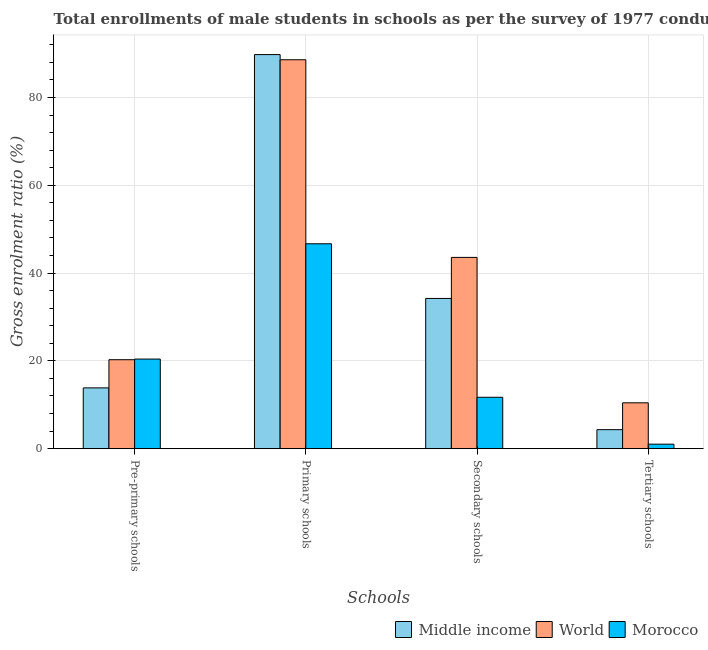How many groups of bars are there?
Make the answer very short. 4. Are the number of bars on each tick of the X-axis equal?
Make the answer very short. Yes. How many bars are there on the 4th tick from the left?
Give a very brief answer. 3. What is the label of the 3rd group of bars from the left?
Ensure brevity in your answer.  Secondary schools. What is the gross enrolment ratio(male) in pre-primary schools in Middle income?
Ensure brevity in your answer.  13.85. Across all countries, what is the maximum gross enrolment ratio(male) in tertiary schools?
Ensure brevity in your answer.  10.44. Across all countries, what is the minimum gross enrolment ratio(male) in pre-primary schools?
Provide a succinct answer. 13.85. In which country was the gross enrolment ratio(male) in secondary schools minimum?
Offer a terse response. Morocco. What is the total gross enrolment ratio(male) in pre-primary schools in the graph?
Your answer should be very brief. 54.52. What is the difference between the gross enrolment ratio(male) in secondary schools in Middle income and that in Morocco?
Your response must be concise. 22.51. What is the difference between the gross enrolment ratio(male) in primary schools in World and the gross enrolment ratio(male) in pre-primary schools in Morocco?
Provide a succinct answer. 68.17. What is the average gross enrolment ratio(male) in secondary schools per country?
Keep it short and to the point. 29.83. What is the difference between the gross enrolment ratio(male) in secondary schools and gross enrolment ratio(male) in pre-primary schools in World?
Offer a terse response. 23.31. In how many countries, is the gross enrolment ratio(male) in primary schools greater than 68 %?
Your answer should be very brief. 2. What is the ratio of the gross enrolment ratio(male) in tertiary schools in Middle income to that in World?
Provide a succinct answer. 0.41. Is the difference between the gross enrolment ratio(male) in primary schools in Morocco and World greater than the difference between the gross enrolment ratio(male) in secondary schools in Morocco and World?
Your response must be concise. No. What is the difference between the highest and the second highest gross enrolment ratio(male) in pre-primary schools?
Make the answer very short. 0.15. What is the difference between the highest and the lowest gross enrolment ratio(male) in pre-primary schools?
Offer a terse response. 6.56. What does the 3rd bar from the left in Pre-primary schools represents?
Your answer should be compact. Morocco. What does the 2nd bar from the right in Pre-primary schools represents?
Your answer should be very brief. World. How many bars are there?
Provide a succinct answer. 12. Are all the bars in the graph horizontal?
Offer a very short reply. No. How many countries are there in the graph?
Provide a succinct answer. 3. Where does the legend appear in the graph?
Keep it short and to the point. Bottom right. What is the title of the graph?
Give a very brief answer. Total enrollments of male students in schools as per the survey of 1977 conducted in different countries. Does "Burkina Faso" appear as one of the legend labels in the graph?
Keep it short and to the point. No. What is the label or title of the X-axis?
Provide a short and direct response. Schools. What is the Gross enrolment ratio (%) in Middle income in Pre-primary schools?
Ensure brevity in your answer.  13.85. What is the Gross enrolment ratio (%) in World in Pre-primary schools?
Make the answer very short. 20.26. What is the Gross enrolment ratio (%) in Morocco in Pre-primary schools?
Provide a succinct answer. 20.41. What is the Gross enrolment ratio (%) in Middle income in Primary schools?
Your answer should be compact. 89.76. What is the Gross enrolment ratio (%) in World in Primary schools?
Provide a short and direct response. 88.58. What is the Gross enrolment ratio (%) in Morocco in Primary schools?
Offer a very short reply. 46.67. What is the Gross enrolment ratio (%) in Middle income in Secondary schools?
Give a very brief answer. 34.22. What is the Gross enrolment ratio (%) of World in Secondary schools?
Provide a succinct answer. 43.57. What is the Gross enrolment ratio (%) in Morocco in Secondary schools?
Make the answer very short. 11.71. What is the Gross enrolment ratio (%) in Middle income in Tertiary schools?
Make the answer very short. 4.33. What is the Gross enrolment ratio (%) in World in Tertiary schools?
Offer a very short reply. 10.44. What is the Gross enrolment ratio (%) in Morocco in Tertiary schools?
Your answer should be compact. 1.03. Across all Schools, what is the maximum Gross enrolment ratio (%) in Middle income?
Provide a succinct answer. 89.76. Across all Schools, what is the maximum Gross enrolment ratio (%) in World?
Offer a very short reply. 88.58. Across all Schools, what is the maximum Gross enrolment ratio (%) in Morocco?
Offer a terse response. 46.67. Across all Schools, what is the minimum Gross enrolment ratio (%) of Middle income?
Ensure brevity in your answer.  4.33. Across all Schools, what is the minimum Gross enrolment ratio (%) of World?
Keep it short and to the point. 10.44. Across all Schools, what is the minimum Gross enrolment ratio (%) of Morocco?
Ensure brevity in your answer.  1.03. What is the total Gross enrolment ratio (%) in Middle income in the graph?
Offer a very short reply. 142.16. What is the total Gross enrolment ratio (%) in World in the graph?
Ensure brevity in your answer.  162.86. What is the total Gross enrolment ratio (%) in Morocco in the graph?
Your answer should be very brief. 79.82. What is the difference between the Gross enrolment ratio (%) of Middle income in Pre-primary schools and that in Primary schools?
Offer a very short reply. -75.92. What is the difference between the Gross enrolment ratio (%) in World in Pre-primary schools and that in Primary schools?
Your response must be concise. -68.32. What is the difference between the Gross enrolment ratio (%) of Morocco in Pre-primary schools and that in Primary schools?
Ensure brevity in your answer.  -26.26. What is the difference between the Gross enrolment ratio (%) of Middle income in Pre-primary schools and that in Secondary schools?
Your response must be concise. -20.37. What is the difference between the Gross enrolment ratio (%) of World in Pre-primary schools and that in Secondary schools?
Give a very brief answer. -23.31. What is the difference between the Gross enrolment ratio (%) in Morocco in Pre-primary schools and that in Secondary schools?
Make the answer very short. 8.7. What is the difference between the Gross enrolment ratio (%) in Middle income in Pre-primary schools and that in Tertiary schools?
Keep it short and to the point. 9.52. What is the difference between the Gross enrolment ratio (%) in World in Pre-primary schools and that in Tertiary schools?
Ensure brevity in your answer.  9.82. What is the difference between the Gross enrolment ratio (%) of Morocco in Pre-primary schools and that in Tertiary schools?
Your answer should be compact. 19.38. What is the difference between the Gross enrolment ratio (%) in Middle income in Primary schools and that in Secondary schools?
Offer a very short reply. 55.55. What is the difference between the Gross enrolment ratio (%) in World in Primary schools and that in Secondary schools?
Offer a very short reply. 45.02. What is the difference between the Gross enrolment ratio (%) in Morocco in Primary schools and that in Secondary schools?
Keep it short and to the point. 34.96. What is the difference between the Gross enrolment ratio (%) of Middle income in Primary schools and that in Tertiary schools?
Ensure brevity in your answer.  85.43. What is the difference between the Gross enrolment ratio (%) in World in Primary schools and that in Tertiary schools?
Provide a short and direct response. 78.14. What is the difference between the Gross enrolment ratio (%) in Morocco in Primary schools and that in Tertiary schools?
Your answer should be very brief. 45.64. What is the difference between the Gross enrolment ratio (%) in Middle income in Secondary schools and that in Tertiary schools?
Your answer should be compact. 29.89. What is the difference between the Gross enrolment ratio (%) of World in Secondary schools and that in Tertiary schools?
Give a very brief answer. 33.12. What is the difference between the Gross enrolment ratio (%) in Morocco in Secondary schools and that in Tertiary schools?
Ensure brevity in your answer.  10.68. What is the difference between the Gross enrolment ratio (%) in Middle income in Pre-primary schools and the Gross enrolment ratio (%) in World in Primary schools?
Your answer should be compact. -74.74. What is the difference between the Gross enrolment ratio (%) in Middle income in Pre-primary schools and the Gross enrolment ratio (%) in Morocco in Primary schools?
Your answer should be compact. -32.82. What is the difference between the Gross enrolment ratio (%) in World in Pre-primary schools and the Gross enrolment ratio (%) in Morocco in Primary schools?
Ensure brevity in your answer.  -26.41. What is the difference between the Gross enrolment ratio (%) of Middle income in Pre-primary schools and the Gross enrolment ratio (%) of World in Secondary schools?
Make the answer very short. -29.72. What is the difference between the Gross enrolment ratio (%) of Middle income in Pre-primary schools and the Gross enrolment ratio (%) of Morocco in Secondary schools?
Give a very brief answer. 2.14. What is the difference between the Gross enrolment ratio (%) in World in Pre-primary schools and the Gross enrolment ratio (%) in Morocco in Secondary schools?
Offer a very short reply. 8.56. What is the difference between the Gross enrolment ratio (%) in Middle income in Pre-primary schools and the Gross enrolment ratio (%) in World in Tertiary schools?
Your answer should be very brief. 3.4. What is the difference between the Gross enrolment ratio (%) in Middle income in Pre-primary schools and the Gross enrolment ratio (%) in Morocco in Tertiary schools?
Your answer should be compact. 12.82. What is the difference between the Gross enrolment ratio (%) in World in Pre-primary schools and the Gross enrolment ratio (%) in Morocco in Tertiary schools?
Make the answer very short. 19.23. What is the difference between the Gross enrolment ratio (%) in Middle income in Primary schools and the Gross enrolment ratio (%) in World in Secondary schools?
Ensure brevity in your answer.  46.2. What is the difference between the Gross enrolment ratio (%) in Middle income in Primary schools and the Gross enrolment ratio (%) in Morocco in Secondary schools?
Ensure brevity in your answer.  78.06. What is the difference between the Gross enrolment ratio (%) of World in Primary schools and the Gross enrolment ratio (%) of Morocco in Secondary schools?
Provide a succinct answer. 76.88. What is the difference between the Gross enrolment ratio (%) in Middle income in Primary schools and the Gross enrolment ratio (%) in World in Tertiary schools?
Your answer should be compact. 79.32. What is the difference between the Gross enrolment ratio (%) in Middle income in Primary schools and the Gross enrolment ratio (%) in Morocco in Tertiary schools?
Give a very brief answer. 88.74. What is the difference between the Gross enrolment ratio (%) in World in Primary schools and the Gross enrolment ratio (%) in Morocco in Tertiary schools?
Provide a short and direct response. 87.56. What is the difference between the Gross enrolment ratio (%) in Middle income in Secondary schools and the Gross enrolment ratio (%) in World in Tertiary schools?
Make the answer very short. 23.77. What is the difference between the Gross enrolment ratio (%) of Middle income in Secondary schools and the Gross enrolment ratio (%) of Morocco in Tertiary schools?
Provide a short and direct response. 33.19. What is the difference between the Gross enrolment ratio (%) in World in Secondary schools and the Gross enrolment ratio (%) in Morocco in Tertiary schools?
Give a very brief answer. 42.54. What is the average Gross enrolment ratio (%) in Middle income per Schools?
Offer a terse response. 35.54. What is the average Gross enrolment ratio (%) in World per Schools?
Provide a succinct answer. 40.72. What is the average Gross enrolment ratio (%) in Morocco per Schools?
Offer a very short reply. 19.95. What is the difference between the Gross enrolment ratio (%) in Middle income and Gross enrolment ratio (%) in World in Pre-primary schools?
Provide a succinct answer. -6.42. What is the difference between the Gross enrolment ratio (%) of Middle income and Gross enrolment ratio (%) of Morocco in Pre-primary schools?
Your response must be concise. -6.56. What is the difference between the Gross enrolment ratio (%) in World and Gross enrolment ratio (%) in Morocco in Pre-primary schools?
Your answer should be compact. -0.15. What is the difference between the Gross enrolment ratio (%) of Middle income and Gross enrolment ratio (%) of World in Primary schools?
Make the answer very short. 1.18. What is the difference between the Gross enrolment ratio (%) in Middle income and Gross enrolment ratio (%) in Morocco in Primary schools?
Provide a succinct answer. 43.09. What is the difference between the Gross enrolment ratio (%) of World and Gross enrolment ratio (%) of Morocco in Primary schools?
Keep it short and to the point. 41.91. What is the difference between the Gross enrolment ratio (%) in Middle income and Gross enrolment ratio (%) in World in Secondary schools?
Offer a terse response. -9.35. What is the difference between the Gross enrolment ratio (%) of Middle income and Gross enrolment ratio (%) of Morocco in Secondary schools?
Your response must be concise. 22.51. What is the difference between the Gross enrolment ratio (%) of World and Gross enrolment ratio (%) of Morocco in Secondary schools?
Your response must be concise. 31.86. What is the difference between the Gross enrolment ratio (%) in Middle income and Gross enrolment ratio (%) in World in Tertiary schools?
Your answer should be compact. -6.11. What is the difference between the Gross enrolment ratio (%) in Middle income and Gross enrolment ratio (%) in Morocco in Tertiary schools?
Offer a terse response. 3.3. What is the difference between the Gross enrolment ratio (%) in World and Gross enrolment ratio (%) in Morocco in Tertiary schools?
Provide a succinct answer. 9.42. What is the ratio of the Gross enrolment ratio (%) in Middle income in Pre-primary schools to that in Primary schools?
Offer a very short reply. 0.15. What is the ratio of the Gross enrolment ratio (%) of World in Pre-primary schools to that in Primary schools?
Your response must be concise. 0.23. What is the ratio of the Gross enrolment ratio (%) of Morocco in Pre-primary schools to that in Primary schools?
Ensure brevity in your answer.  0.44. What is the ratio of the Gross enrolment ratio (%) in Middle income in Pre-primary schools to that in Secondary schools?
Provide a short and direct response. 0.4. What is the ratio of the Gross enrolment ratio (%) of World in Pre-primary schools to that in Secondary schools?
Make the answer very short. 0.47. What is the ratio of the Gross enrolment ratio (%) in Morocco in Pre-primary schools to that in Secondary schools?
Your answer should be compact. 1.74. What is the ratio of the Gross enrolment ratio (%) of Middle income in Pre-primary schools to that in Tertiary schools?
Provide a succinct answer. 3.2. What is the ratio of the Gross enrolment ratio (%) in World in Pre-primary schools to that in Tertiary schools?
Your response must be concise. 1.94. What is the ratio of the Gross enrolment ratio (%) in Morocco in Pre-primary schools to that in Tertiary schools?
Your response must be concise. 19.83. What is the ratio of the Gross enrolment ratio (%) of Middle income in Primary schools to that in Secondary schools?
Make the answer very short. 2.62. What is the ratio of the Gross enrolment ratio (%) of World in Primary schools to that in Secondary schools?
Provide a succinct answer. 2.03. What is the ratio of the Gross enrolment ratio (%) in Morocco in Primary schools to that in Secondary schools?
Ensure brevity in your answer.  3.99. What is the ratio of the Gross enrolment ratio (%) in Middle income in Primary schools to that in Tertiary schools?
Your answer should be compact. 20.73. What is the ratio of the Gross enrolment ratio (%) in World in Primary schools to that in Tertiary schools?
Make the answer very short. 8.48. What is the ratio of the Gross enrolment ratio (%) of Morocco in Primary schools to that in Tertiary schools?
Offer a terse response. 45.35. What is the ratio of the Gross enrolment ratio (%) of Middle income in Secondary schools to that in Tertiary schools?
Your answer should be very brief. 7.9. What is the ratio of the Gross enrolment ratio (%) in World in Secondary schools to that in Tertiary schools?
Provide a succinct answer. 4.17. What is the ratio of the Gross enrolment ratio (%) in Morocco in Secondary schools to that in Tertiary schools?
Your response must be concise. 11.38. What is the difference between the highest and the second highest Gross enrolment ratio (%) in Middle income?
Your response must be concise. 55.55. What is the difference between the highest and the second highest Gross enrolment ratio (%) of World?
Ensure brevity in your answer.  45.02. What is the difference between the highest and the second highest Gross enrolment ratio (%) of Morocco?
Your answer should be compact. 26.26. What is the difference between the highest and the lowest Gross enrolment ratio (%) in Middle income?
Offer a terse response. 85.43. What is the difference between the highest and the lowest Gross enrolment ratio (%) in World?
Offer a terse response. 78.14. What is the difference between the highest and the lowest Gross enrolment ratio (%) in Morocco?
Your answer should be very brief. 45.64. 